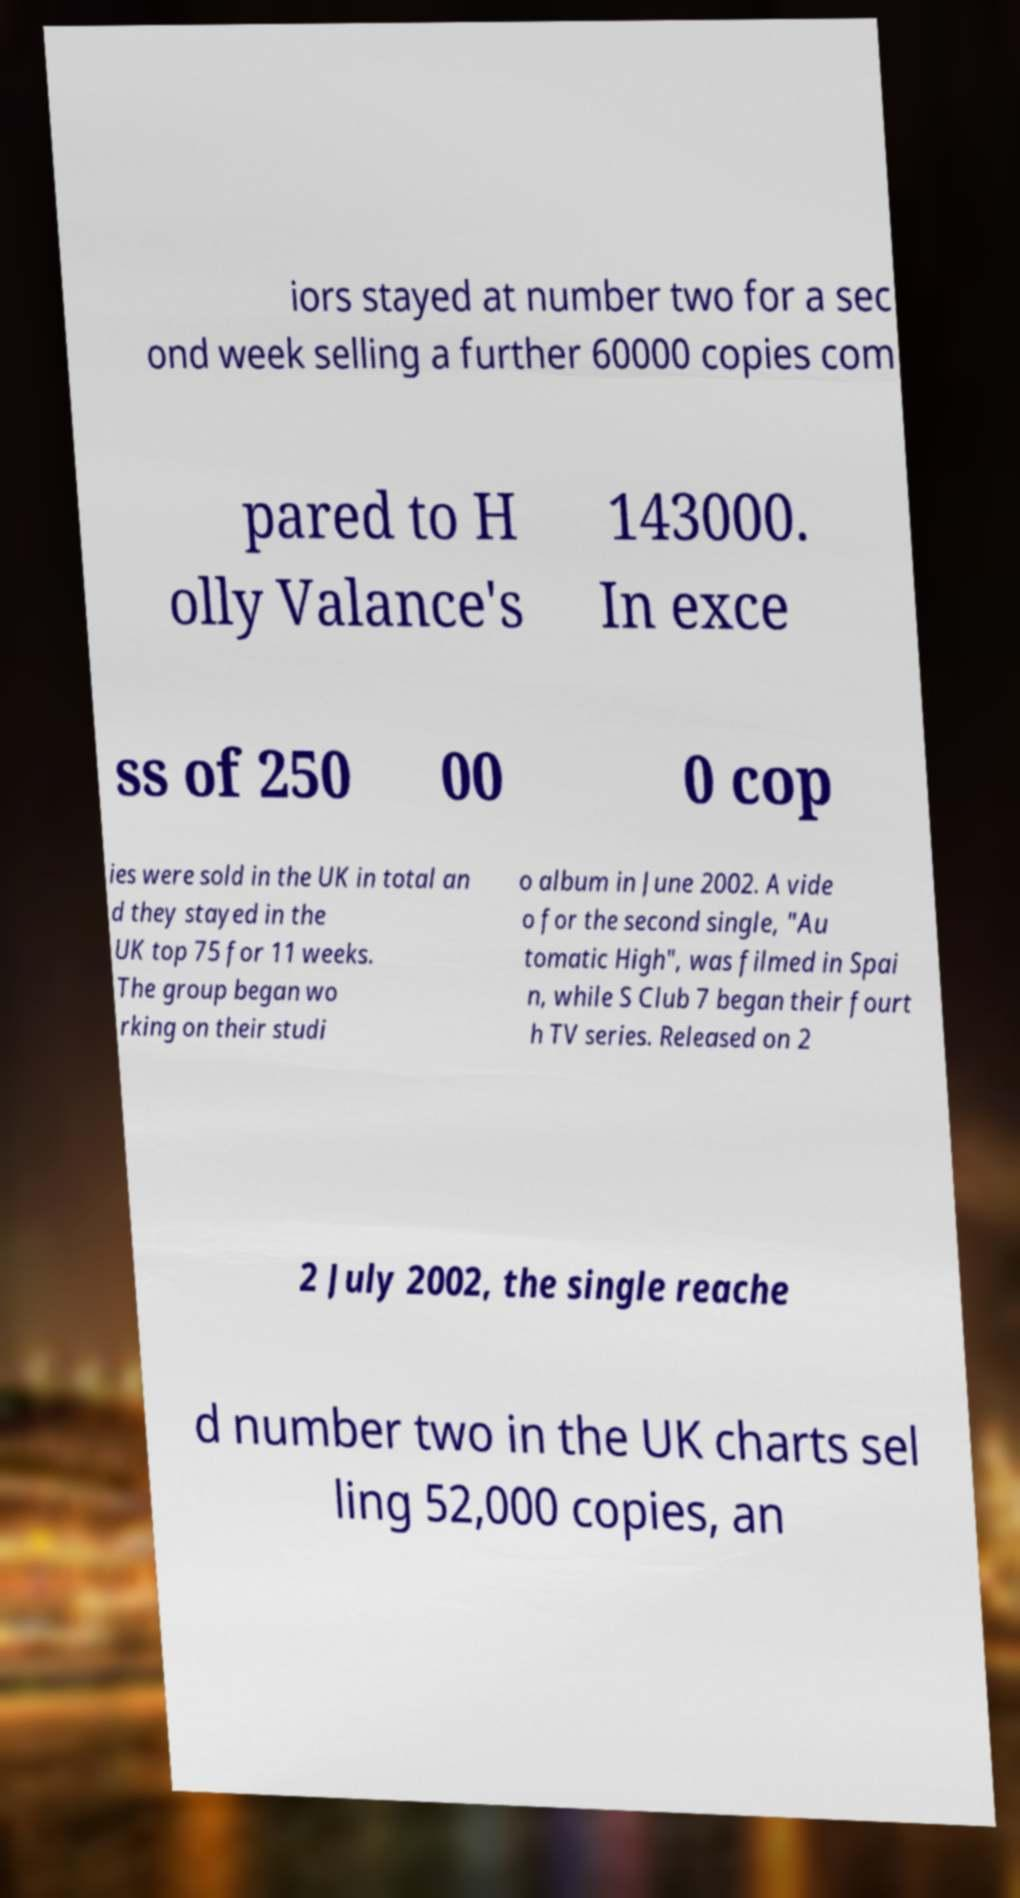Can you read and provide the text displayed in the image?This photo seems to have some interesting text. Can you extract and type it out for me? iors stayed at number two for a sec ond week selling a further 60000 copies com pared to H olly Valance's 143000. In exce ss of 250 00 0 cop ies were sold in the UK in total an d they stayed in the UK top 75 for 11 weeks. The group began wo rking on their studi o album in June 2002. A vide o for the second single, "Au tomatic High", was filmed in Spai n, while S Club 7 began their fourt h TV series. Released on 2 2 July 2002, the single reache d number two in the UK charts sel ling 52,000 copies, an 